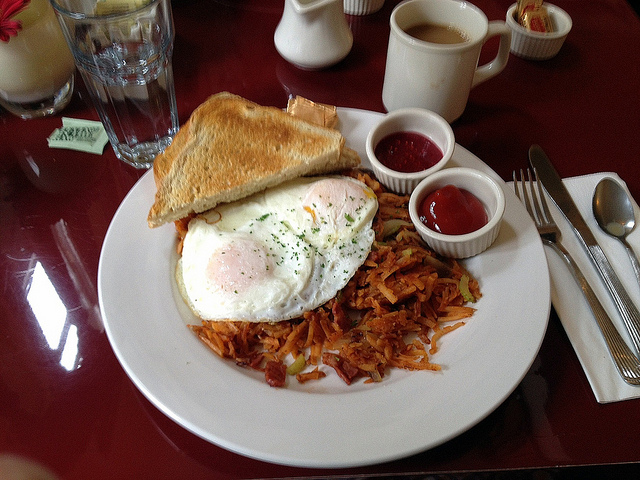Are there any utensils visible in the image? Yes, the image clearly shows a silver fork and knife placed neatly on a napkin to the left of the plate, indicating the meal is ready to be eaten. 